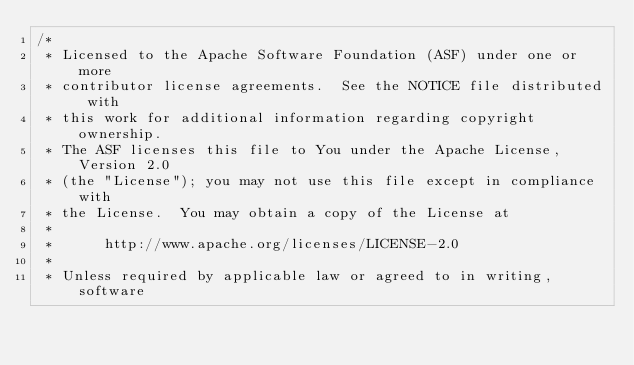<code> <loc_0><loc_0><loc_500><loc_500><_Java_>/*
 * Licensed to the Apache Software Foundation (ASF) under one or more
 * contributor license agreements.  See the NOTICE file distributed with
 * this work for additional information regarding copyright ownership.
 * The ASF licenses this file to You under the Apache License, Version 2.0
 * (the "License"); you may not use this file except in compliance with
 * the License.  You may obtain a copy of the License at
 *
 *      http://www.apache.org/licenses/LICENSE-2.0
 *
 * Unless required by applicable law or agreed to in writing, software</code> 